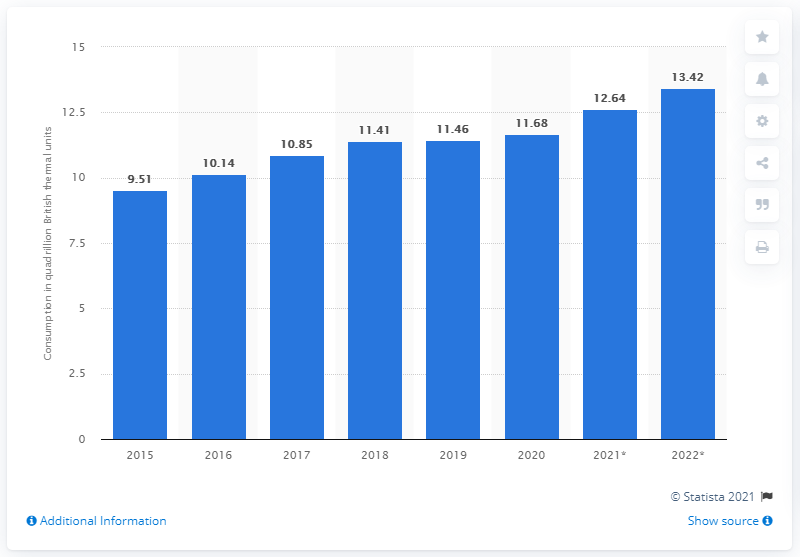Highlight a few significant elements in this photo. In the year 2020, the electric power sector in the United States reached its highest consumption of renewable energy. 